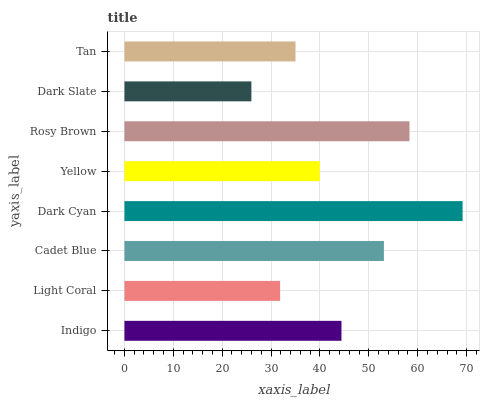Is Dark Slate the minimum?
Answer yes or no. Yes. Is Dark Cyan the maximum?
Answer yes or no. Yes. Is Light Coral the minimum?
Answer yes or no. No. Is Light Coral the maximum?
Answer yes or no. No. Is Indigo greater than Light Coral?
Answer yes or no. Yes. Is Light Coral less than Indigo?
Answer yes or no. Yes. Is Light Coral greater than Indigo?
Answer yes or no. No. Is Indigo less than Light Coral?
Answer yes or no. No. Is Indigo the high median?
Answer yes or no. Yes. Is Yellow the low median?
Answer yes or no. Yes. Is Tan the high median?
Answer yes or no. No. Is Tan the low median?
Answer yes or no. No. 